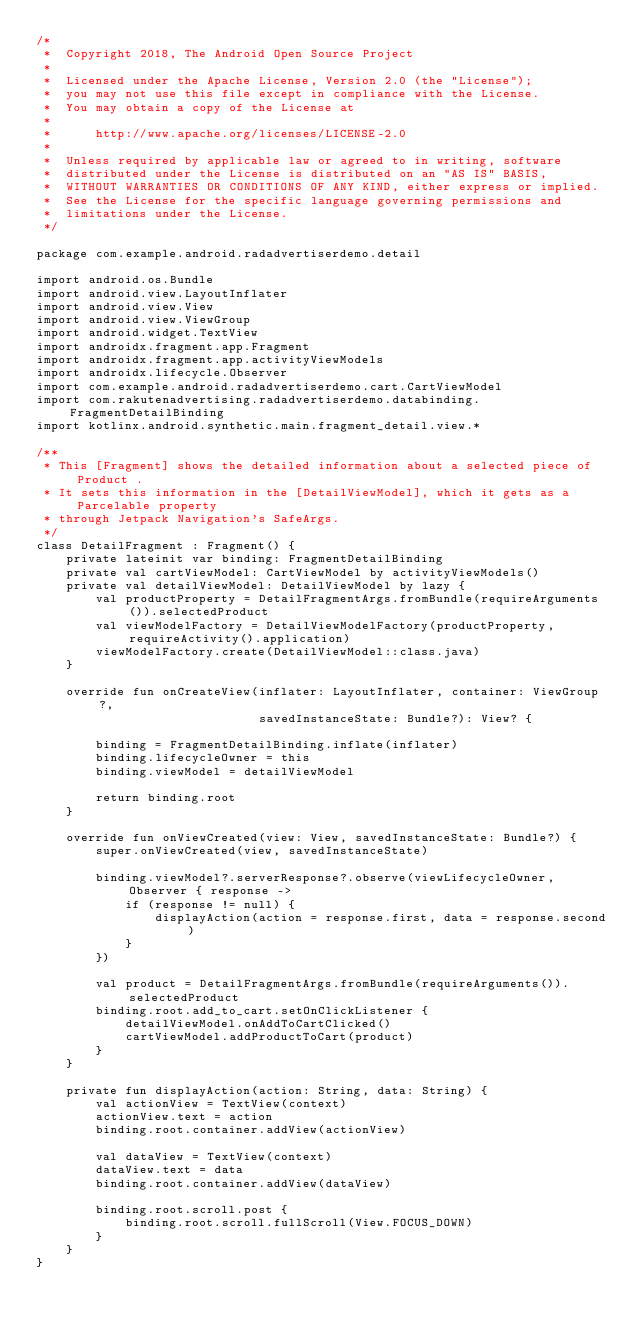<code> <loc_0><loc_0><loc_500><loc_500><_Kotlin_>/*
 *  Copyright 2018, The Android Open Source Project
 *
 *  Licensed under the Apache License, Version 2.0 (the "License");
 *  you may not use this file except in compliance with the License.
 *  You may obtain a copy of the License at
 *
 *      http://www.apache.org/licenses/LICENSE-2.0
 *
 *  Unless required by applicable law or agreed to in writing, software
 *  distributed under the License is distributed on an "AS IS" BASIS,
 *  WITHOUT WARRANTIES OR CONDITIONS OF ANY KIND, either express or implied.
 *  See the License for the specific language governing permissions and
 *  limitations under the License.
 */

package com.example.android.radadvertiserdemo.detail

import android.os.Bundle
import android.view.LayoutInflater
import android.view.View
import android.view.ViewGroup
import android.widget.TextView
import androidx.fragment.app.Fragment
import androidx.fragment.app.activityViewModels
import androidx.lifecycle.Observer
import com.example.android.radadvertiserdemo.cart.CartViewModel
import com.rakutenadvertising.radadvertiserdemo.databinding.FragmentDetailBinding
import kotlinx.android.synthetic.main.fragment_detail.view.*

/**
 * This [Fragment] shows the detailed information about a selected piece of Product .
 * It sets this information in the [DetailViewModel], which it gets as a Parcelable property
 * through Jetpack Navigation's SafeArgs.
 */
class DetailFragment : Fragment() {
    private lateinit var binding: FragmentDetailBinding
    private val cartViewModel: CartViewModel by activityViewModels()
    private val detailViewModel: DetailViewModel by lazy {
        val productProperty = DetailFragmentArgs.fromBundle(requireArguments()).selectedProduct
        val viewModelFactory = DetailViewModelFactory(productProperty, requireActivity().application)
        viewModelFactory.create(DetailViewModel::class.java)
    }

    override fun onCreateView(inflater: LayoutInflater, container: ViewGroup?,
                              savedInstanceState: Bundle?): View? {

        binding = FragmentDetailBinding.inflate(inflater)
        binding.lifecycleOwner = this
        binding.viewModel = detailViewModel

        return binding.root
    }

    override fun onViewCreated(view: View, savedInstanceState: Bundle?) {
        super.onViewCreated(view, savedInstanceState)

        binding.viewModel?.serverResponse?.observe(viewLifecycleOwner, Observer { response ->
            if (response != null) {
                displayAction(action = response.first, data = response.second)
            }
        })

        val product = DetailFragmentArgs.fromBundle(requireArguments()).selectedProduct
        binding.root.add_to_cart.setOnClickListener {
            detailViewModel.onAddToCartClicked()
            cartViewModel.addProductToCart(product)
        }
    }

    private fun displayAction(action: String, data: String) {
        val actionView = TextView(context)
        actionView.text = action
        binding.root.container.addView(actionView)

        val dataView = TextView(context)
        dataView.text = data
        binding.root.container.addView(dataView)

        binding.root.scroll.post {
            binding.root.scroll.fullScroll(View.FOCUS_DOWN)
        }
    }
}</code> 